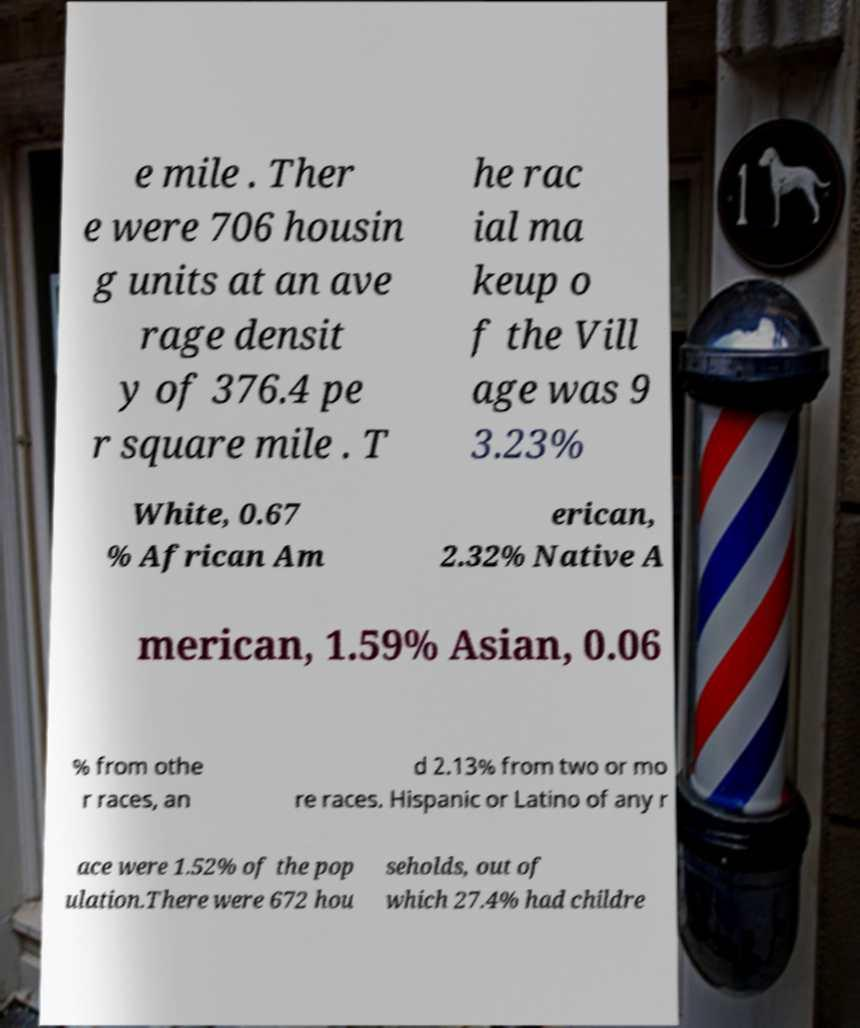Can you read and provide the text displayed in the image?This photo seems to have some interesting text. Can you extract and type it out for me? e mile . Ther e were 706 housin g units at an ave rage densit y of 376.4 pe r square mile . T he rac ial ma keup o f the Vill age was 9 3.23% White, 0.67 % African Am erican, 2.32% Native A merican, 1.59% Asian, 0.06 % from othe r races, an d 2.13% from two or mo re races. Hispanic or Latino of any r ace were 1.52% of the pop ulation.There were 672 hou seholds, out of which 27.4% had childre 